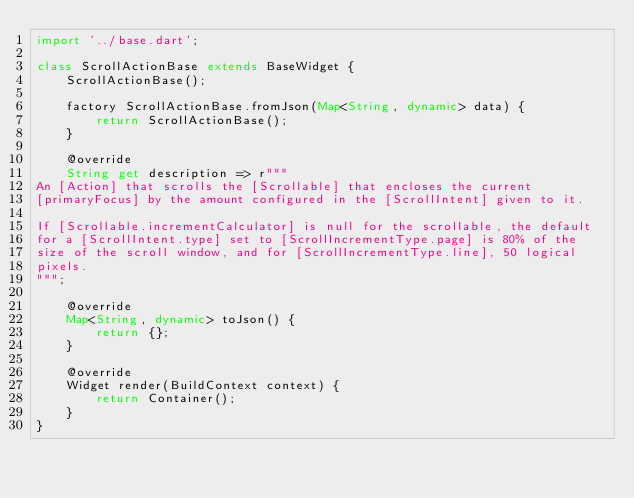Convert code to text. <code><loc_0><loc_0><loc_500><loc_500><_Dart_>import '../base.dart';

class ScrollActionBase extends BaseWidget {
    ScrollActionBase();

    factory ScrollActionBase.fromJson(Map<String, dynamic> data) {
        return ScrollActionBase();
    }

    @override
    String get description => r"""
An [Action] that scrolls the [Scrollable] that encloses the current
[primaryFocus] by the amount configured in the [ScrollIntent] given to it.

If [Scrollable.incrementCalculator] is null for the scrollable, the default
for a [ScrollIntent.type] set to [ScrollIncrementType.page] is 80% of the
size of the scroll window, and for [ScrollIncrementType.line], 50 logical
pixels.
""";

    @override
    Map<String, dynamic> toJson() {
        return {};
    }

    @override
    Widget render(BuildContext context) {
        return Container();
    }
}</code> 